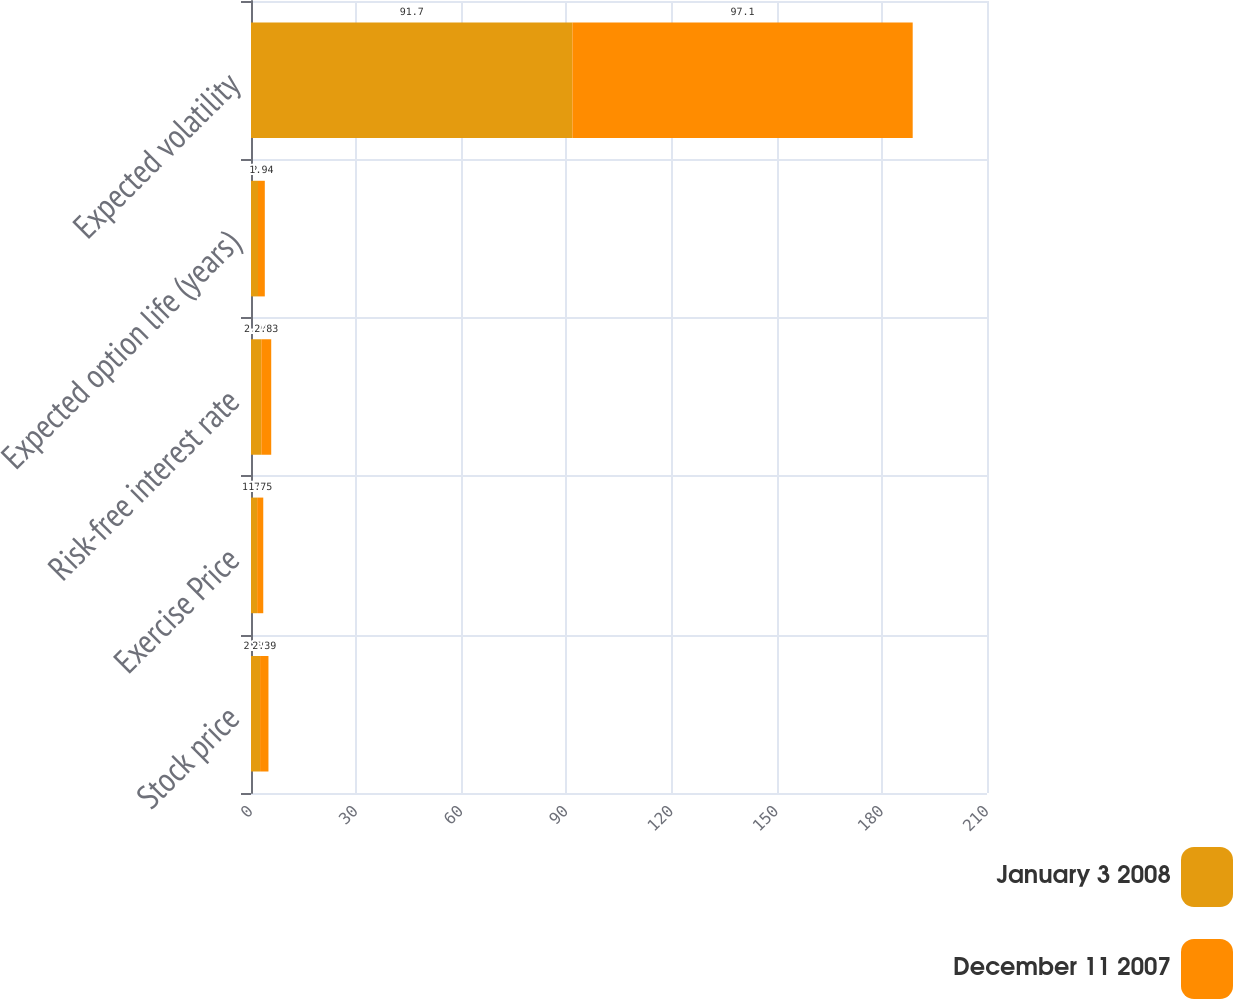<chart> <loc_0><loc_0><loc_500><loc_500><stacked_bar_chart><ecel><fcel>Stock price<fcel>Exercise Price<fcel>Risk-free interest rate<fcel>Expected option life (years)<fcel>Expected volatility<nl><fcel>January 3 2008<fcel>2.59<fcel>1.75<fcel>2.94<fcel>2<fcel>91.7<nl><fcel>December 11 2007<fcel>2.39<fcel>1.75<fcel>2.83<fcel>1.94<fcel>97.1<nl></chart> 